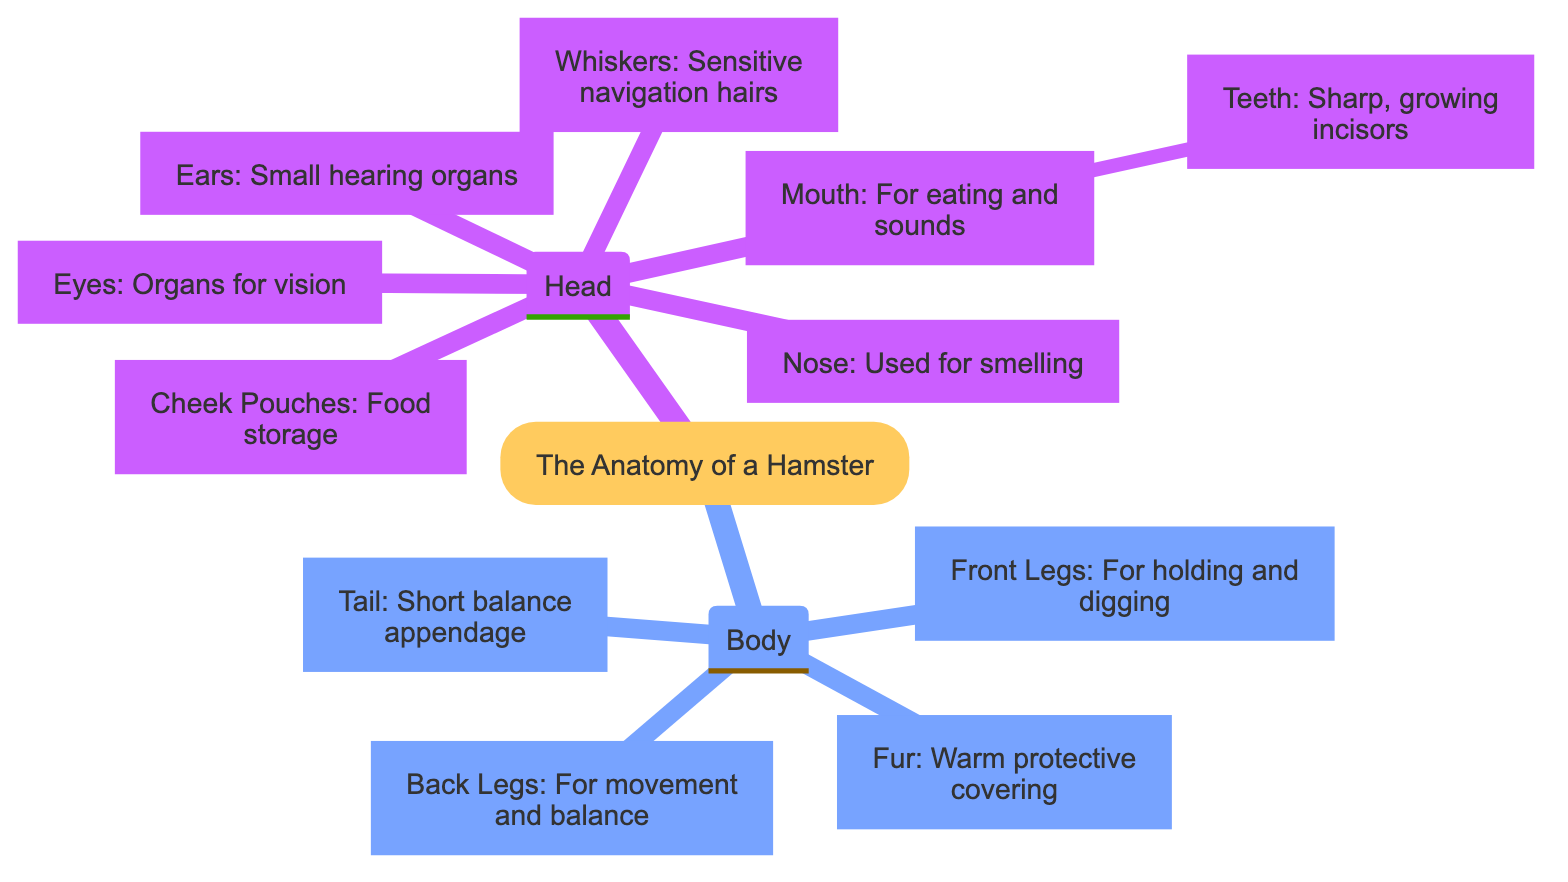What are the organs for vision in a hamster? The diagram shows that the "Eyes" are specifically labeled as "Organs for vision." Therefore, when asked about the organs for vision, we look directly at the label associated with the "Eyes."
Answer: Eyes What part of the hamster is used for smelling? According to the diagram, the "Nose" is identified as "Used for smelling." This label indicates that the nose is the specific body part for the sense of smell.
Answer: Nose How many main parts are there in the hamster's anatomy? The diagram consists of two main sections labeled "Head" and "Body." By counting these sections, we determine the total number of main parts.
Answer: 2 What is the purpose of the cheek pouches? The label for "Cheek Pouches" in the diagram states "Food storage." Thus, the purpose of the cheek pouches is directly indicated in their description.
Answer: Food storage What feature helps a hamster to navigate? The diagram indicates that "Whiskers" are described as "Sensitive navigation hairs." Therefore, whiskers are the features that assist hamsters in navigation.
Answer: Whiskers Which legs are used for movement and balance? Based on the diagram, "Back Legs" are labeled for their purpose: "For movement and balance." This tells us that the back legs carry this function.
Answer: Back Legs What part contains sharp, growing incisors? The diagram specifies that "Teeth" includes the description "Sharp, growing incisors." By referencing the information in the diagram, we identify the teeth as the part with incisors.
Answer: Teeth What is the function of the tail? The "Tail" is described in the diagram as a "Short balance appendage." This indicates that the main function of the tail is related to balance.
Answer: Short balance appendage What part of the hamster is covered by fur? The diagram mentions "Fur" as "Warm protective covering." This means that the fur covers the body of the hamster providing warmth and protection.
Answer: Fur 